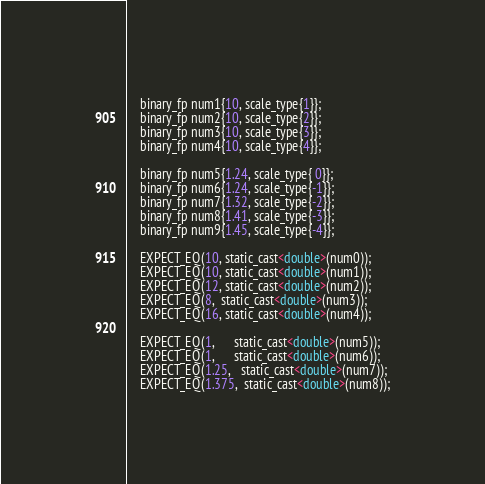<code> <loc_0><loc_0><loc_500><loc_500><_Cuda_>    binary_fp num1{10, scale_type{1}};
    binary_fp num2{10, scale_type{2}};
    binary_fp num3{10, scale_type{3}};
    binary_fp num4{10, scale_type{4}};

    binary_fp num5{1.24, scale_type{ 0}};
    binary_fp num6{1.24, scale_type{-1}};
    binary_fp num7{1.32, scale_type{-2}};
    binary_fp num8{1.41, scale_type{-3}};
    binary_fp num9{1.45, scale_type{-4}};

    EXPECT_EQ(10, static_cast<double>(num0));
    EXPECT_EQ(10, static_cast<double>(num1));
    EXPECT_EQ(12, static_cast<double>(num2));
    EXPECT_EQ(8,  static_cast<double>(num3));
    EXPECT_EQ(16, static_cast<double>(num4));

    EXPECT_EQ(1,      static_cast<double>(num5));
    EXPECT_EQ(1,      static_cast<double>(num6));
    EXPECT_EQ(1.25,   static_cast<double>(num7));
    EXPECT_EQ(1.375,  static_cast<double>(num8));</code> 